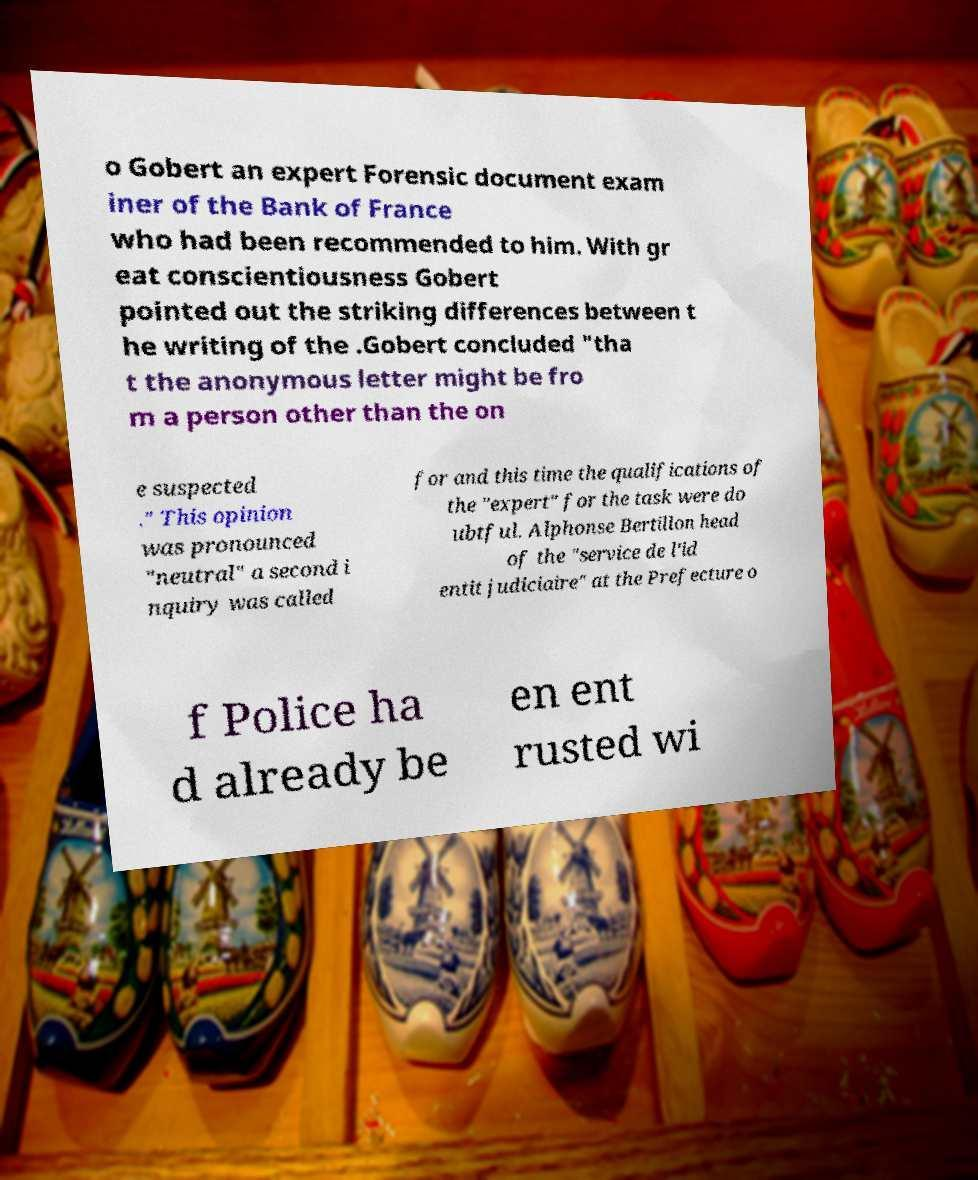I need the written content from this picture converted into text. Can you do that? o Gobert an expert Forensic document exam iner of the Bank of France who had been recommended to him. With gr eat conscientiousness Gobert pointed out the striking differences between t he writing of the .Gobert concluded "tha t the anonymous letter might be fro m a person other than the on e suspected ." This opinion was pronounced "neutral" a second i nquiry was called for and this time the qualifications of the "expert" for the task were do ubtful. Alphonse Bertillon head of the "service de l'id entit judiciaire" at the Prefecture o f Police ha d already be en ent rusted wi 